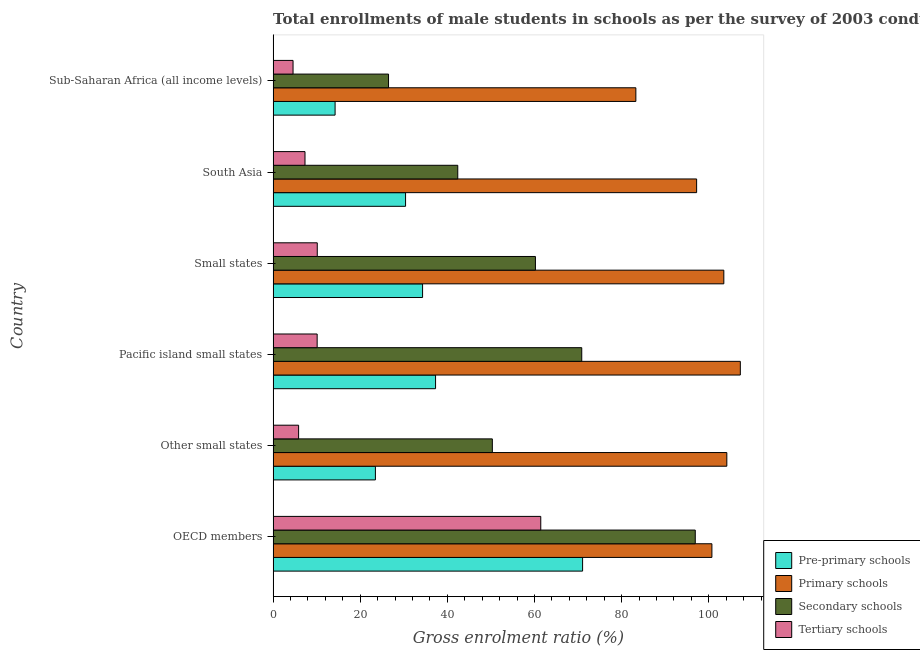How many different coloured bars are there?
Keep it short and to the point. 4. How many bars are there on the 6th tick from the top?
Provide a succinct answer. 4. How many bars are there on the 6th tick from the bottom?
Provide a short and direct response. 4. What is the label of the 1st group of bars from the top?
Give a very brief answer. Sub-Saharan Africa (all income levels). In how many cases, is the number of bars for a given country not equal to the number of legend labels?
Provide a succinct answer. 0. What is the gross enrolment ratio(male) in tertiary schools in Sub-Saharan Africa (all income levels)?
Provide a succinct answer. 4.57. Across all countries, what is the maximum gross enrolment ratio(male) in pre-primary schools?
Provide a short and direct response. 71.04. Across all countries, what is the minimum gross enrolment ratio(male) in secondary schools?
Provide a short and direct response. 26.49. In which country was the gross enrolment ratio(male) in primary schools maximum?
Give a very brief answer. Pacific island small states. In which country was the gross enrolment ratio(male) in primary schools minimum?
Your answer should be very brief. Sub-Saharan Africa (all income levels). What is the total gross enrolment ratio(male) in primary schools in the graph?
Offer a terse response. 596.04. What is the difference between the gross enrolment ratio(male) in secondary schools in South Asia and that in Sub-Saharan Africa (all income levels)?
Your answer should be compact. 15.89. What is the difference between the gross enrolment ratio(male) in secondary schools in South Asia and the gross enrolment ratio(male) in tertiary schools in OECD members?
Ensure brevity in your answer.  -19.05. What is the average gross enrolment ratio(male) in primary schools per country?
Offer a terse response. 99.34. What is the difference between the gross enrolment ratio(male) in pre-primary schools and gross enrolment ratio(male) in tertiary schools in Pacific island small states?
Offer a very short reply. 27.18. In how many countries, is the gross enrolment ratio(male) in secondary schools greater than 108 %?
Provide a short and direct response. 0. What is the ratio of the gross enrolment ratio(male) in primary schools in Other small states to that in Pacific island small states?
Ensure brevity in your answer.  0.97. Is the difference between the gross enrolment ratio(male) in tertiary schools in OECD members and Small states greater than the difference between the gross enrolment ratio(male) in secondary schools in OECD members and Small states?
Offer a terse response. Yes. What is the difference between the highest and the second highest gross enrolment ratio(male) in secondary schools?
Offer a terse response. 26.06. What is the difference between the highest and the lowest gross enrolment ratio(male) in primary schools?
Your response must be concise. 23.98. Is the sum of the gross enrolment ratio(male) in primary schools in Small states and Sub-Saharan Africa (all income levels) greater than the maximum gross enrolment ratio(male) in secondary schools across all countries?
Give a very brief answer. Yes. Is it the case that in every country, the sum of the gross enrolment ratio(male) in pre-primary schools and gross enrolment ratio(male) in tertiary schools is greater than the sum of gross enrolment ratio(male) in secondary schools and gross enrolment ratio(male) in primary schools?
Give a very brief answer. No. What does the 1st bar from the top in OECD members represents?
Offer a very short reply. Tertiary schools. What does the 2nd bar from the bottom in Pacific island small states represents?
Your answer should be very brief. Primary schools. How many bars are there?
Offer a very short reply. 24. How many countries are there in the graph?
Your answer should be compact. 6. Where does the legend appear in the graph?
Ensure brevity in your answer.  Bottom right. How many legend labels are there?
Offer a terse response. 4. What is the title of the graph?
Your response must be concise. Total enrollments of male students in schools as per the survey of 2003 conducted in different countries. What is the label or title of the X-axis?
Keep it short and to the point. Gross enrolment ratio (%). What is the label or title of the Y-axis?
Ensure brevity in your answer.  Country. What is the Gross enrolment ratio (%) in Pre-primary schools in OECD members?
Your answer should be compact. 71.04. What is the Gross enrolment ratio (%) in Primary schools in OECD members?
Your answer should be very brief. 100.72. What is the Gross enrolment ratio (%) of Secondary schools in OECD members?
Provide a succinct answer. 96.9. What is the Gross enrolment ratio (%) of Tertiary schools in OECD members?
Offer a terse response. 61.44. What is the Gross enrolment ratio (%) in Pre-primary schools in Other small states?
Give a very brief answer. 23.48. What is the Gross enrolment ratio (%) of Primary schools in Other small states?
Give a very brief answer. 104.15. What is the Gross enrolment ratio (%) of Secondary schools in Other small states?
Offer a terse response. 50.32. What is the Gross enrolment ratio (%) of Tertiary schools in Other small states?
Give a very brief answer. 5.85. What is the Gross enrolment ratio (%) in Pre-primary schools in Pacific island small states?
Your response must be concise. 37.29. What is the Gross enrolment ratio (%) in Primary schools in Pacific island small states?
Provide a succinct answer. 107.25. What is the Gross enrolment ratio (%) in Secondary schools in Pacific island small states?
Ensure brevity in your answer.  70.84. What is the Gross enrolment ratio (%) in Tertiary schools in Pacific island small states?
Keep it short and to the point. 10.11. What is the Gross enrolment ratio (%) in Pre-primary schools in Small states?
Your answer should be very brief. 34.31. What is the Gross enrolment ratio (%) of Primary schools in Small states?
Make the answer very short. 103.46. What is the Gross enrolment ratio (%) of Secondary schools in Small states?
Keep it short and to the point. 60.21. What is the Gross enrolment ratio (%) in Tertiary schools in Small states?
Ensure brevity in your answer.  10.13. What is the Gross enrolment ratio (%) in Pre-primary schools in South Asia?
Give a very brief answer. 30.4. What is the Gross enrolment ratio (%) in Primary schools in South Asia?
Your answer should be very brief. 97.21. What is the Gross enrolment ratio (%) in Secondary schools in South Asia?
Provide a short and direct response. 42.38. What is the Gross enrolment ratio (%) in Tertiary schools in South Asia?
Make the answer very short. 7.32. What is the Gross enrolment ratio (%) of Pre-primary schools in Sub-Saharan Africa (all income levels)?
Ensure brevity in your answer.  14.22. What is the Gross enrolment ratio (%) of Primary schools in Sub-Saharan Africa (all income levels)?
Give a very brief answer. 83.26. What is the Gross enrolment ratio (%) of Secondary schools in Sub-Saharan Africa (all income levels)?
Offer a very short reply. 26.49. What is the Gross enrolment ratio (%) of Tertiary schools in Sub-Saharan Africa (all income levels)?
Give a very brief answer. 4.57. Across all countries, what is the maximum Gross enrolment ratio (%) in Pre-primary schools?
Make the answer very short. 71.04. Across all countries, what is the maximum Gross enrolment ratio (%) in Primary schools?
Your answer should be very brief. 107.25. Across all countries, what is the maximum Gross enrolment ratio (%) in Secondary schools?
Your response must be concise. 96.9. Across all countries, what is the maximum Gross enrolment ratio (%) in Tertiary schools?
Provide a succinct answer. 61.44. Across all countries, what is the minimum Gross enrolment ratio (%) of Pre-primary schools?
Your answer should be very brief. 14.22. Across all countries, what is the minimum Gross enrolment ratio (%) in Primary schools?
Provide a short and direct response. 83.26. Across all countries, what is the minimum Gross enrolment ratio (%) of Secondary schools?
Provide a short and direct response. 26.49. Across all countries, what is the minimum Gross enrolment ratio (%) in Tertiary schools?
Your response must be concise. 4.57. What is the total Gross enrolment ratio (%) of Pre-primary schools in the graph?
Offer a terse response. 210.74. What is the total Gross enrolment ratio (%) in Primary schools in the graph?
Make the answer very short. 596.04. What is the total Gross enrolment ratio (%) in Secondary schools in the graph?
Ensure brevity in your answer.  347.14. What is the total Gross enrolment ratio (%) of Tertiary schools in the graph?
Your response must be concise. 99.42. What is the difference between the Gross enrolment ratio (%) in Pre-primary schools in OECD members and that in Other small states?
Give a very brief answer. 47.56. What is the difference between the Gross enrolment ratio (%) in Primary schools in OECD members and that in Other small states?
Your answer should be compact. -3.43. What is the difference between the Gross enrolment ratio (%) in Secondary schools in OECD members and that in Other small states?
Give a very brief answer. 46.58. What is the difference between the Gross enrolment ratio (%) of Tertiary schools in OECD members and that in Other small states?
Provide a succinct answer. 55.59. What is the difference between the Gross enrolment ratio (%) in Pre-primary schools in OECD members and that in Pacific island small states?
Provide a succinct answer. 33.75. What is the difference between the Gross enrolment ratio (%) in Primary schools in OECD members and that in Pacific island small states?
Your response must be concise. -6.53. What is the difference between the Gross enrolment ratio (%) in Secondary schools in OECD members and that in Pacific island small states?
Your response must be concise. 26.06. What is the difference between the Gross enrolment ratio (%) of Tertiary schools in OECD members and that in Pacific island small states?
Your answer should be compact. 51.33. What is the difference between the Gross enrolment ratio (%) in Pre-primary schools in OECD members and that in Small states?
Your response must be concise. 36.73. What is the difference between the Gross enrolment ratio (%) of Primary schools in OECD members and that in Small states?
Offer a terse response. -2.74. What is the difference between the Gross enrolment ratio (%) of Secondary schools in OECD members and that in Small states?
Keep it short and to the point. 36.69. What is the difference between the Gross enrolment ratio (%) of Tertiary schools in OECD members and that in Small states?
Your answer should be compact. 51.3. What is the difference between the Gross enrolment ratio (%) of Pre-primary schools in OECD members and that in South Asia?
Make the answer very short. 40.64. What is the difference between the Gross enrolment ratio (%) of Primary schools in OECD members and that in South Asia?
Offer a very short reply. 3.51. What is the difference between the Gross enrolment ratio (%) in Secondary schools in OECD members and that in South Asia?
Keep it short and to the point. 54.52. What is the difference between the Gross enrolment ratio (%) of Tertiary schools in OECD members and that in South Asia?
Provide a succinct answer. 54.12. What is the difference between the Gross enrolment ratio (%) of Pre-primary schools in OECD members and that in Sub-Saharan Africa (all income levels)?
Keep it short and to the point. 56.81. What is the difference between the Gross enrolment ratio (%) of Primary schools in OECD members and that in Sub-Saharan Africa (all income levels)?
Offer a terse response. 17.46. What is the difference between the Gross enrolment ratio (%) in Secondary schools in OECD members and that in Sub-Saharan Africa (all income levels)?
Offer a terse response. 70.41. What is the difference between the Gross enrolment ratio (%) of Tertiary schools in OECD members and that in Sub-Saharan Africa (all income levels)?
Give a very brief answer. 56.86. What is the difference between the Gross enrolment ratio (%) in Pre-primary schools in Other small states and that in Pacific island small states?
Your answer should be very brief. -13.81. What is the difference between the Gross enrolment ratio (%) of Primary schools in Other small states and that in Pacific island small states?
Your response must be concise. -3.1. What is the difference between the Gross enrolment ratio (%) of Secondary schools in Other small states and that in Pacific island small states?
Your answer should be very brief. -20.52. What is the difference between the Gross enrolment ratio (%) of Tertiary schools in Other small states and that in Pacific island small states?
Your answer should be very brief. -4.26. What is the difference between the Gross enrolment ratio (%) of Pre-primary schools in Other small states and that in Small states?
Your answer should be very brief. -10.83. What is the difference between the Gross enrolment ratio (%) of Primary schools in Other small states and that in Small states?
Provide a short and direct response. 0.69. What is the difference between the Gross enrolment ratio (%) in Secondary schools in Other small states and that in Small states?
Offer a very short reply. -9.89. What is the difference between the Gross enrolment ratio (%) of Tertiary schools in Other small states and that in Small states?
Your answer should be very brief. -4.28. What is the difference between the Gross enrolment ratio (%) of Pre-primary schools in Other small states and that in South Asia?
Your response must be concise. -6.92. What is the difference between the Gross enrolment ratio (%) of Primary schools in Other small states and that in South Asia?
Ensure brevity in your answer.  6.94. What is the difference between the Gross enrolment ratio (%) in Secondary schools in Other small states and that in South Asia?
Your response must be concise. 7.94. What is the difference between the Gross enrolment ratio (%) of Tertiary schools in Other small states and that in South Asia?
Give a very brief answer. -1.47. What is the difference between the Gross enrolment ratio (%) in Pre-primary schools in Other small states and that in Sub-Saharan Africa (all income levels)?
Make the answer very short. 9.25. What is the difference between the Gross enrolment ratio (%) of Primary schools in Other small states and that in Sub-Saharan Africa (all income levels)?
Your response must be concise. 20.88. What is the difference between the Gross enrolment ratio (%) of Secondary schools in Other small states and that in Sub-Saharan Africa (all income levels)?
Offer a very short reply. 23.83. What is the difference between the Gross enrolment ratio (%) of Tertiary schools in Other small states and that in Sub-Saharan Africa (all income levels)?
Give a very brief answer. 1.28. What is the difference between the Gross enrolment ratio (%) of Pre-primary schools in Pacific island small states and that in Small states?
Offer a very short reply. 2.98. What is the difference between the Gross enrolment ratio (%) of Primary schools in Pacific island small states and that in Small states?
Ensure brevity in your answer.  3.79. What is the difference between the Gross enrolment ratio (%) in Secondary schools in Pacific island small states and that in Small states?
Your answer should be compact. 10.63. What is the difference between the Gross enrolment ratio (%) in Tertiary schools in Pacific island small states and that in Small states?
Your response must be concise. -0.03. What is the difference between the Gross enrolment ratio (%) in Pre-primary schools in Pacific island small states and that in South Asia?
Give a very brief answer. 6.89. What is the difference between the Gross enrolment ratio (%) in Primary schools in Pacific island small states and that in South Asia?
Ensure brevity in your answer.  10.04. What is the difference between the Gross enrolment ratio (%) of Secondary schools in Pacific island small states and that in South Asia?
Provide a short and direct response. 28.46. What is the difference between the Gross enrolment ratio (%) in Tertiary schools in Pacific island small states and that in South Asia?
Your answer should be very brief. 2.79. What is the difference between the Gross enrolment ratio (%) in Pre-primary schools in Pacific island small states and that in Sub-Saharan Africa (all income levels)?
Provide a succinct answer. 23.06. What is the difference between the Gross enrolment ratio (%) of Primary schools in Pacific island small states and that in Sub-Saharan Africa (all income levels)?
Provide a short and direct response. 23.98. What is the difference between the Gross enrolment ratio (%) of Secondary schools in Pacific island small states and that in Sub-Saharan Africa (all income levels)?
Offer a very short reply. 44.35. What is the difference between the Gross enrolment ratio (%) in Tertiary schools in Pacific island small states and that in Sub-Saharan Africa (all income levels)?
Your response must be concise. 5.53. What is the difference between the Gross enrolment ratio (%) in Pre-primary schools in Small states and that in South Asia?
Your answer should be very brief. 3.91. What is the difference between the Gross enrolment ratio (%) of Primary schools in Small states and that in South Asia?
Ensure brevity in your answer.  6.25. What is the difference between the Gross enrolment ratio (%) of Secondary schools in Small states and that in South Asia?
Your response must be concise. 17.83. What is the difference between the Gross enrolment ratio (%) of Tertiary schools in Small states and that in South Asia?
Offer a very short reply. 2.81. What is the difference between the Gross enrolment ratio (%) in Pre-primary schools in Small states and that in Sub-Saharan Africa (all income levels)?
Ensure brevity in your answer.  20.08. What is the difference between the Gross enrolment ratio (%) of Primary schools in Small states and that in Sub-Saharan Africa (all income levels)?
Ensure brevity in your answer.  20.2. What is the difference between the Gross enrolment ratio (%) of Secondary schools in Small states and that in Sub-Saharan Africa (all income levels)?
Offer a very short reply. 33.72. What is the difference between the Gross enrolment ratio (%) in Tertiary schools in Small states and that in Sub-Saharan Africa (all income levels)?
Keep it short and to the point. 5.56. What is the difference between the Gross enrolment ratio (%) of Pre-primary schools in South Asia and that in Sub-Saharan Africa (all income levels)?
Your answer should be compact. 16.18. What is the difference between the Gross enrolment ratio (%) of Primary schools in South Asia and that in Sub-Saharan Africa (all income levels)?
Provide a succinct answer. 13.95. What is the difference between the Gross enrolment ratio (%) in Secondary schools in South Asia and that in Sub-Saharan Africa (all income levels)?
Provide a short and direct response. 15.89. What is the difference between the Gross enrolment ratio (%) of Tertiary schools in South Asia and that in Sub-Saharan Africa (all income levels)?
Your response must be concise. 2.74. What is the difference between the Gross enrolment ratio (%) of Pre-primary schools in OECD members and the Gross enrolment ratio (%) of Primary schools in Other small states?
Your answer should be compact. -33.11. What is the difference between the Gross enrolment ratio (%) in Pre-primary schools in OECD members and the Gross enrolment ratio (%) in Secondary schools in Other small states?
Give a very brief answer. 20.72. What is the difference between the Gross enrolment ratio (%) of Pre-primary schools in OECD members and the Gross enrolment ratio (%) of Tertiary schools in Other small states?
Offer a very short reply. 65.19. What is the difference between the Gross enrolment ratio (%) of Primary schools in OECD members and the Gross enrolment ratio (%) of Secondary schools in Other small states?
Your response must be concise. 50.4. What is the difference between the Gross enrolment ratio (%) of Primary schools in OECD members and the Gross enrolment ratio (%) of Tertiary schools in Other small states?
Provide a short and direct response. 94.87. What is the difference between the Gross enrolment ratio (%) in Secondary schools in OECD members and the Gross enrolment ratio (%) in Tertiary schools in Other small states?
Offer a very short reply. 91.05. What is the difference between the Gross enrolment ratio (%) of Pre-primary schools in OECD members and the Gross enrolment ratio (%) of Primary schools in Pacific island small states?
Your answer should be compact. -36.21. What is the difference between the Gross enrolment ratio (%) in Pre-primary schools in OECD members and the Gross enrolment ratio (%) in Secondary schools in Pacific island small states?
Offer a very short reply. 0.2. What is the difference between the Gross enrolment ratio (%) in Pre-primary schools in OECD members and the Gross enrolment ratio (%) in Tertiary schools in Pacific island small states?
Your answer should be very brief. 60.93. What is the difference between the Gross enrolment ratio (%) in Primary schools in OECD members and the Gross enrolment ratio (%) in Secondary schools in Pacific island small states?
Your answer should be compact. 29.88. What is the difference between the Gross enrolment ratio (%) of Primary schools in OECD members and the Gross enrolment ratio (%) of Tertiary schools in Pacific island small states?
Keep it short and to the point. 90.61. What is the difference between the Gross enrolment ratio (%) in Secondary schools in OECD members and the Gross enrolment ratio (%) in Tertiary schools in Pacific island small states?
Your answer should be very brief. 86.79. What is the difference between the Gross enrolment ratio (%) of Pre-primary schools in OECD members and the Gross enrolment ratio (%) of Primary schools in Small states?
Keep it short and to the point. -32.42. What is the difference between the Gross enrolment ratio (%) in Pre-primary schools in OECD members and the Gross enrolment ratio (%) in Secondary schools in Small states?
Offer a terse response. 10.83. What is the difference between the Gross enrolment ratio (%) in Pre-primary schools in OECD members and the Gross enrolment ratio (%) in Tertiary schools in Small states?
Give a very brief answer. 60.9. What is the difference between the Gross enrolment ratio (%) in Primary schools in OECD members and the Gross enrolment ratio (%) in Secondary schools in Small states?
Your answer should be very brief. 40.51. What is the difference between the Gross enrolment ratio (%) in Primary schools in OECD members and the Gross enrolment ratio (%) in Tertiary schools in Small states?
Keep it short and to the point. 90.59. What is the difference between the Gross enrolment ratio (%) of Secondary schools in OECD members and the Gross enrolment ratio (%) of Tertiary schools in Small states?
Offer a very short reply. 86.77. What is the difference between the Gross enrolment ratio (%) of Pre-primary schools in OECD members and the Gross enrolment ratio (%) of Primary schools in South Asia?
Your response must be concise. -26.17. What is the difference between the Gross enrolment ratio (%) of Pre-primary schools in OECD members and the Gross enrolment ratio (%) of Secondary schools in South Asia?
Offer a terse response. 28.66. What is the difference between the Gross enrolment ratio (%) in Pre-primary schools in OECD members and the Gross enrolment ratio (%) in Tertiary schools in South Asia?
Provide a short and direct response. 63.72. What is the difference between the Gross enrolment ratio (%) of Primary schools in OECD members and the Gross enrolment ratio (%) of Secondary schools in South Asia?
Make the answer very short. 58.34. What is the difference between the Gross enrolment ratio (%) of Primary schools in OECD members and the Gross enrolment ratio (%) of Tertiary schools in South Asia?
Ensure brevity in your answer.  93.4. What is the difference between the Gross enrolment ratio (%) in Secondary schools in OECD members and the Gross enrolment ratio (%) in Tertiary schools in South Asia?
Provide a succinct answer. 89.58. What is the difference between the Gross enrolment ratio (%) of Pre-primary schools in OECD members and the Gross enrolment ratio (%) of Primary schools in Sub-Saharan Africa (all income levels)?
Your answer should be compact. -12.22. What is the difference between the Gross enrolment ratio (%) in Pre-primary schools in OECD members and the Gross enrolment ratio (%) in Secondary schools in Sub-Saharan Africa (all income levels)?
Your answer should be very brief. 44.55. What is the difference between the Gross enrolment ratio (%) in Pre-primary schools in OECD members and the Gross enrolment ratio (%) in Tertiary schools in Sub-Saharan Africa (all income levels)?
Your answer should be very brief. 66.46. What is the difference between the Gross enrolment ratio (%) of Primary schools in OECD members and the Gross enrolment ratio (%) of Secondary schools in Sub-Saharan Africa (all income levels)?
Provide a succinct answer. 74.23. What is the difference between the Gross enrolment ratio (%) in Primary schools in OECD members and the Gross enrolment ratio (%) in Tertiary schools in Sub-Saharan Africa (all income levels)?
Ensure brevity in your answer.  96.14. What is the difference between the Gross enrolment ratio (%) of Secondary schools in OECD members and the Gross enrolment ratio (%) of Tertiary schools in Sub-Saharan Africa (all income levels)?
Offer a terse response. 92.32. What is the difference between the Gross enrolment ratio (%) of Pre-primary schools in Other small states and the Gross enrolment ratio (%) of Primary schools in Pacific island small states?
Offer a terse response. -83.77. What is the difference between the Gross enrolment ratio (%) of Pre-primary schools in Other small states and the Gross enrolment ratio (%) of Secondary schools in Pacific island small states?
Give a very brief answer. -47.36. What is the difference between the Gross enrolment ratio (%) of Pre-primary schools in Other small states and the Gross enrolment ratio (%) of Tertiary schools in Pacific island small states?
Provide a short and direct response. 13.37. What is the difference between the Gross enrolment ratio (%) of Primary schools in Other small states and the Gross enrolment ratio (%) of Secondary schools in Pacific island small states?
Provide a short and direct response. 33.3. What is the difference between the Gross enrolment ratio (%) of Primary schools in Other small states and the Gross enrolment ratio (%) of Tertiary schools in Pacific island small states?
Keep it short and to the point. 94.04. What is the difference between the Gross enrolment ratio (%) of Secondary schools in Other small states and the Gross enrolment ratio (%) of Tertiary schools in Pacific island small states?
Your response must be concise. 40.21. What is the difference between the Gross enrolment ratio (%) of Pre-primary schools in Other small states and the Gross enrolment ratio (%) of Primary schools in Small states?
Your response must be concise. -79.98. What is the difference between the Gross enrolment ratio (%) in Pre-primary schools in Other small states and the Gross enrolment ratio (%) in Secondary schools in Small states?
Ensure brevity in your answer.  -36.73. What is the difference between the Gross enrolment ratio (%) of Pre-primary schools in Other small states and the Gross enrolment ratio (%) of Tertiary schools in Small states?
Offer a terse response. 13.35. What is the difference between the Gross enrolment ratio (%) in Primary schools in Other small states and the Gross enrolment ratio (%) in Secondary schools in Small states?
Offer a very short reply. 43.94. What is the difference between the Gross enrolment ratio (%) of Primary schools in Other small states and the Gross enrolment ratio (%) of Tertiary schools in Small states?
Offer a terse response. 94.01. What is the difference between the Gross enrolment ratio (%) of Secondary schools in Other small states and the Gross enrolment ratio (%) of Tertiary schools in Small states?
Your response must be concise. 40.19. What is the difference between the Gross enrolment ratio (%) in Pre-primary schools in Other small states and the Gross enrolment ratio (%) in Primary schools in South Asia?
Make the answer very short. -73.73. What is the difference between the Gross enrolment ratio (%) of Pre-primary schools in Other small states and the Gross enrolment ratio (%) of Secondary schools in South Asia?
Keep it short and to the point. -18.9. What is the difference between the Gross enrolment ratio (%) in Pre-primary schools in Other small states and the Gross enrolment ratio (%) in Tertiary schools in South Asia?
Provide a short and direct response. 16.16. What is the difference between the Gross enrolment ratio (%) in Primary schools in Other small states and the Gross enrolment ratio (%) in Secondary schools in South Asia?
Your answer should be compact. 61.76. What is the difference between the Gross enrolment ratio (%) of Primary schools in Other small states and the Gross enrolment ratio (%) of Tertiary schools in South Asia?
Your answer should be compact. 96.83. What is the difference between the Gross enrolment ratio (%) in Secondary schools in Other small states and the Gross enrolment ratio (%) in Tertiary schools in South Asia?
Your answer should be compact. 43. What is the difference between the Gross enrolment ratio (%) in Pre-primary schools in Other small states and the Gross enrolment ratio (%) in Primary schools in Sub-Saharan Africa (all income levels)?
Keep it short and to the point. -59.78. What is the difference between the Gross enrolment ratio (%) in Pre-primary schools in Other small states and the Gross enrolment ratio (%) in Secondary schools in Sub-Saharan Africa (all income levels)?
Keep it short and to the point. -3.01. What is the difference between the Gross enrolment ratio (%) of Pre-primary schools in Other small states and the Gross enrolment ratio (%) of Tertiary schools in Sub-Saharan Africa (all income levels)?
Your response must be concise. 18.9. What is the difference between the Gross enrolment ratio (%) in Primary schools in Other small states and the Gross enrolment ratio (%) in Secondary schools in Sub-Saharan Africa (all income levels)?
Keep it short and to the point. 77.66. What is the difference between the Gross enrolment ratio (%) in Primary schools in Other small states and the Gross enrolment ratio (%) in Tertiary schools in Sub-Saharan Africa (all income levels)?
Provide a short and direct response. 99.57. What is the difference between the Gross enrolment ratio (%) in Secondary schools in Other small states and the Gross enrolment ratio (%) in Tertiary schools in Sub-Saharan Africa (all income levels)?
Keep it short and to the point. 45.75. What is the difference between the Gross enrolment ratio (%) of Pre-primary schools in Pacific island small states and the Gross enrolment ratio (%) of Primary schools in Small states?
Ensure brevity in your answer.  -66.17. What is the difference between the Gross enrolment ratio (%) in Pre-primary schools in Pacific island small states and the Gross enrolment ratio (%) in Secondary schools in Small states?
Your answer should be very brief. -22.92. What is the difference between the Gross enrolment ratio (%) of Pre-primary schools in Pacific island small states and the Gross enrolment ratio (%) of Tertiary schools in Small states?
Offer a very short reply. 27.16. What is the difference between the Gross enrolment ratio (%) of Primary schools in Pacific island small states and the Gross enrolment ratio (%) of Secondary schools in Small states?
Provide a succinct answer. 47.04. What is the difference between the Gross enrolment ratio (%) in Primary schools in Pacific island small states and the Gross enrolment ratio (%) in Tertiary schools in Small states?
Your answer should be compact. 97.11. What is the difference between the Gross enrolment ratio (%) in Secondary schools in Pacific island small states and the Gross enrolment ratio (%) in Tertiary schools in Small states?
Your answer should be very brief. 60.71. What is the difference between the Gross enrolment ratio (%) in Pre-primary schools in Pacific island small states and the Gross enrolment ratio (%) in Primary schools in South Asia?
Provide a short and direct response. -59.92. What is the difference between the Gross enrolment ratio (%) of Pre-primary schools in Pacific island small states and the Gross enrolment ratio (%) of Secondary schools in South Asia?
Offer a terse response. -5.09. What is the difference between the Gross enrolment ratio (%) of Pre-primary schools in Pacific island small states and the Gross enrolment ratio (%) of Tertiary schools in South Asia?
Make the answer very short. 29.97. What is the difference between the Gross enrolment ratio (%) of Primary schools in Pacific island small states and the Gross enrolment ratio (%) of Secondary schools in South Asia?
Provide a succinct answer. 64.86. What is the difference between the Gross enrolment ratio (%) of Primary schools in Pacific island small states and the Gross enrolment ratio (%) of Tertiary schools in South Asia?
Provide a succinct answer. 99.93. What is the difference between the Gross enrolment ratio (%) of Secondary schools in Pacific island small states and the Gross enrolment ratio (%) of Tertiary schools in South Asia?
Provide a short and direct response. 63.52. What is the difference between the Gross enrolment ratio (%) of Pre-primary schools in Pacific island small states and the Gross enrolment ratio (%) of Primary schools in Sub-Saharan Africa (all income levels)?
Provide a succinct answer. -45.97. What is the difference between the Gross enrolment ratio (%) of Pre-primary schools in Pacific island small states and the Gross enrolment ratio (%) of Secondary schools in Sub-Saharan Africa (all income levels)?
Your answer should be very brief. 10.8. What is the difference between the Gross enrolment ratio (%) in Pre-primary schools in Pacific island small states and the Gross enrolment ratio (%) in Tertiary schools in Sub-Saharan Africa (all income levels)?
Keep it short and to the point. 32.71. What is the difference between the Gross enrolment ratio (%) in Primary schools in Pacific island small states and the Gross enrolment ratio (%) in Secondary schools in Sub-Saharan Africa (all income levels)?
Offer a terse response. 80.75. What is the difference between the Gross enrolment ratio (%) in Primary schools in Pacific island small states and the Gross enrolment ratio (%) in Tertiary schools in Sub-Saharan Africa (all income levels)?
Provide a short and direct response. 102.67. What is the difference between the Gross enrolment ratio (%) of Secondary schools in Pacific island small states and the Gross enrolment ratio (%) of Tertiary schools in Sub-Saharan Africa (all income levels)?
Keep it short and to the point. 66.27. What is the difference between the Gross enrolment ratio (%) of Pre-primary schools in Small states and the Gross enrolment ratio (%) of Primary schools in South Asia?
Keep it short and to the point. -62.9. What is the difference between the Gross enrolment ratio (%) in Pre-primary schools in Small states and the Gross enrolment ratio (%) in Secondary schools in South Asia?
Ensure brevity in your answer.  -8.08. What is the difference between the Gross enrolment ratio (%) in Pre-primary schools in Small states and the Gross enrolment ratio (%) in Tertiary schools in South Asia?
Give a very brief answer. 26.99. What is the difference between the Gross enrolment ratio (%) in Primary schools in Small states and the Gross enrolment ratio (%) in Secondary schools in South Asia?
Make the answer very short. 61.08. What is the difference between the Gross enrolment ratio (%) of Primary schools in Small states and the Gross enrolment ratio (%) of Tertiary schools in South Asia?
Your answer should be compact. 96.14. What is the difference between the Gross enrolment ratio (%) in Secondary schools in Small states and the Gross enrolment ratio (%) in Tertiary schools in South Asia?
Your response must be concise. 52.89. What is the difference between the Gross enrolment ratio (%) in Pre-primary schools in Small states and the Gross enrolment ratio (%) in Primary schools in Sub-Saharan Africa (all income levels)?
Your response must be concise. -48.96. What is the difference between the Gross enrolment ratio (%) in Pre-primary schools in Small states and the Gross enrolment ratio (%) in Secondary schools in Sub-Saharan Africa (all income levels)?
Ensure brevity in your answer.  7.81. What is the difference between the Gross enrolment ratio (%) in Pre-primary schools in Small states and the Gross enrolment ratio (%) in Tertiary schools in Sub-Saharan Africa (all income levels)?
Offer a terse response. 29.73. What is the difference between the Gross enrolment ratio (%) of Primary schools in Small states and the Gross enrolment ratio (%) of Secondary schools in Sub-Saharan Africa (all income levels)?
Ensure brevity in your answer.  76.97. What is the difference between the Gross enrolment ratio (%) in Primary schools in Small states and the Gross enrolment ratio (%) in Tertiary schools in Sub-Saharan Africa (all income levels)?
Your answer should be compact. 98.88. What is the difference between the Gross enrolment ratio (%) in Secondary schools in Small states and the Gross enrolment ratio (%) in Tertiary schools in Sub-Saharan Africa (all income levels)?
Your answer should be compact. 55.63. What is the difference between the Gross enrolment ratio (%) in Pre-primary schools in South Asia and the Gross enrolment ratio (%) in Primary schools in Sub-Saharan Africa (all income levels)?
Give a very brief answer. -52.86. What is the difference between the Gross enrolment ratio (%) of Pre-primary schools in South Asia and the Gross enrolment ratio (%) of Secondary schools in Sub-Saharan Africa (all income levels)?
Offer a very short reply. 3.91. What is the difference between the Gross enrolment ratio (%) of Pre-primary schools in South Asia and the Gross enrolment ratio (%) of Tertiary schools in Sub-Saharan Africa (all income levels)?
Provide a succinct answer. 25.83. What is the difference between the Gross enrolment ratio (%) of Primary schools in South Asia and the Gross enrolment ratio (%) of Secondary schools in Sub-Saharan Africa (all income levels)?
Keep it short and to the point. 70.72. What is the difference between the Gross enrolment ratio (%) in Primary schools in South Asia and the Gross enrolment ratio (%) in Tertiary schools in Sub-Saharan Africa (all income levels)?
Offer a very short reply. 92.64. What is the difference between the Gross enrolment ratio (%) in Secondary schools in South Asia and the Gross enrolment ratio (%) in Tertiary schools in Sub-Saharan Africa (all income levels)?
Offer a terse response. 37.81. What is the average Gross enrolment ratio (%) of Pre-primary schools per country?
Provide a succinct answer. 35.12. What is the average Gross enrolment ratio (%) of Primary schools per country?
Offer a very short reply. 99.34. What is the average Gross enrolment ratio (%) of Secondary schools per country?
Your response must be concise. 57.86. What is the average Gross enrolment ratio (%) of Tertiary schools per country?
Keep it short and to the point. 16.57. What is the difference between the Gross enrolment ratio (%) of Pre-primary schools and Gross enrolment ratio (%) of Primary schools in OECD members?
Offer a terse response. -29.68. What is the difference between the Gross enrolment ratio (%) of Pre-primary schools and Gross enrolment ratio (%) of Secondary schools in OECD members?
Your answer should be very brief. -25.86. What is the difference between the Gross enrolment ratio (%) of Pre-primary schools and Gross enrolment ratio (%) of Tertiary schools in OECD members?
Offer a very short reply. 9.6. What is the difference between the Gross enrolment ratio (%) of Primary schools and Gross enrolment ratio (%) of Secondary schools in OECD members?
Provide a succinct answer. 3.82. What is the difference between the Gross enrolment ratio (%) of Primary schools and Gross enrolment ratio (%) of Tertiary schools in OECD members?
Provide a succinct answer. 39.28. What is the difference between the Gross enrolment ratio (%) in Secondary schools and Gross enrolment ratio (%) in Tertiary schools in OECD members?
Provide a short and direct response. 35.46. What is the difference between the Gross enrolment ratio (%) of Pre-primary schools and Gross enrolment ratio (%) of Primary schools in Other small states?
Ensure brevity in your answer.  -80.67. What is the difference between the Gross enrolment ratio (%) of Pre-primary schools and Gross enrolment ratio (%) of Secondary schools in Other small states?
Ensure brevity in your answer.  -26.84. What is the difference between the Gross enrolment ratio (%) in Pre-primary schools and Gross enrolment ratio (%) in Tertiary schools in Other small states?
Your answer should be very brief. 17.63. What is the difference between the Gross enrolment ratio (%) in Primary schools and Gross enrolment ratio (%) in Secondary schools in Other small states?
Provide a succinct answer. 53.83. What is the difference between the Gross enrolment ratio (%) in Primary schools and Gross enrolment ratio (%) in Tertiary schools in Other small states?
Your response must be concise. 98.3. What is the difference between the Gross enrolment ratio (%) in Secondary schools and Gross enrolment ratio (%) in Tertiary schools in Other small states?
Provide a short and direct response. 44.47. What is the difference between the Gross enrolment ratio (%) in Pre-primary schools and Gross enrolment ratio (%) in Primary schools in Pacific island small states?
Offer a terse response. -69.96. What is the difference between the Gross enrolment ratio (%) of Pre-primary schools and Gross enrolment ratio (%) of Secondary schools in Pacific island small states?
Keep it short and to the point. -33.55. What is the difference between the Gross enrolment ratio (%) in Pre-primary schools and Gross enrolment ratio (%) in Tertiary schools in Pacific island small states?
Give a very brief answer. 27.18. What is the difference between the Gross enrolment ratio (%) of Primary schools and Gross enrolment ratio (%) of Secondary schools in Pacific island small states?
Give a very brief answer. 36.4. What is the difference between the Gross enrolment ratio (%) of Primary schools and Gross enrolment ratio (%) of Tertiary schools in Pacific island small states?
Give a very brief answer. 97.14. What is the difference between the Gross enrolment ratio (%) of Secondary schools and Gross enrolment ratio (%) of Tertiary schools in Pacific island small states?
Provide a succinct answer. 60.73. What is the difference between the Gross enrolment ratio (%) of Pre-primary schools and Gross enrolment ratio (%) of Primary schools in Small states?
Keep it short and to the point. -69.15. What is the difference between the Gross enrolment ratio (%) of Pre-primary schools and Gross enrolment ratio (%) of Secondary schools in Small states?
Offer a very short reply. -25.9. What is the difference between the Gross enrolment ratio (%) of Pre-primary schools and Gross enrolment ratio (%) of Tertiary schools in Small states?
Offer a terse response. 24.17. What is the difference between the Gross enrolment ratio (%) of Primary schools and Gross enrolment ratio (%) of Secondary schools in Small states?
Give a very brief answer. 43.25. What is the difference between the Gross enrolment ratio (%) of Primary schools and Gross enrolment ratio (%) of Tertiary schools in Small states?
Offer a very short reply. 93.33. What is the difference between the Gross enrolment ratio (%) in Secondary schools and Gross enrolment ratio (%) in Tertiary schools in Small states?
Provide a short and direct response. 50.08. What is the difference between the Gross enrolment ratio (%) of Pre-primary schools and Gross enrolment ratio (%) of Primary schools in South Asia?
Ensure brevity in your answer.  -66.81. What is the difference between the Gross enrolment ratio (%) in Pre-primary schools and Gross enrolment ratio (%) in Secondary schools in South Asia?
Your answer should be very brief. -11.98. What is the difference between the Gross enrolment ratio (%) in Pre-primary schools and Gross enrolment ratio (%) in Tertiary schools in South Asia?
Ensure brevity in your answer.  23.08. What is the difference between the Gross enrolment ratio (%) of Primary schools and Gross enrolment ratio (%) of Secondary schools in South Asia?
Provide a short and direct response. 54.83. What is the difference between the Gross enrolment ratio (%) of Primary schools and Gross enrolment ratio (%) of Tertiary schools in South Asia?
Your response must be concise. 89.89. What is the difference between the Gross enrolment ratio (%) of Secondary schools and Gross enrolment ratio (%) of Tertiary schools in South Asia?
Provide a short and direct response. 35.06. What is the difference between the Gross enrolment ratio (%) in Pre-primary schools and Gross enrolment ratio (%) in Primary schools in Sub-Saharan Africa (all income levels)?
Your answer should be compact. -69.04. What is the difference between the Gross enrolment ratio (%) of Pre-primary schools and Gross enrolment ratio (%) of Secondary schools in Sub-Saharan Africa (all income levels)?
Ensure brevity in your answer.  -12.27. What is the difference between the Gross enrolment ratio (%) of Pre-primary schools and Gross enrolment ratio (%) of Tertiary schools in Sub-Saharan Africa (all income levels)?
Offer a terse response. 9.65. What is the difference between the Gross enrolment ratio (%) of Primary schools and Gross enrolment ratio (%) of Secondary schools in Sub-Saharan Africa (all income levels)?
Offer a very short reply. 56.77. What is the difference between the Gross enrolment ratio (%) of Primary schools and Gross enrolment ratio (%) of Tertiary schools in Sub-Saharan Africa (all income levels)?
Offer a very short reply. 78.69. What is the difference between the Gross enrolment ratio (%) in Secondary schools and Gross enrolment ratio (%) in Tertiary schools in Sub-Saharan Africa (all income levels)?
Provide a succinct answer. 21.92. What is the ratio of the Gross enrolment ratio (%) in Pre-primary schools in OECD members to that in Other small states?
Your answer should be very brief. 3.03. What is the ratio of the Gross enrolment ratio (%) in Primary schools in OECD members to that in Other small states?
Provide a short and direct response. 0.97. What is the ratio of the Gross enrolment ratio (%) of Secondary schools in OECD members to that in Other small states?
Your response must be concise. 1.93. What is the ratio of the Gross enrolment ratio (%) in Tertiary schools in OECD members to that in Other small states?
Offer a terse response. 10.5. What is the ratio of the Gross enrolment ratio (%) in Pre-primary schools in OECD members to that in Pacific island small states?
Your response must be concise. 1.91. What is the ratio of the Gross enrolment ratio (%) of Primary schools in OECD members to that in Pacific island small states?
Provide a succinct answer. 0.94. What is the ratio of the Gross enrolment ratio (%) of Secondary schools in OECD members to that in Pacific island small states?
Keep it short and to the point. 1.37. What is the ratio of the Gross enrolment ratio (%) in Tertiary schools in OECD members to that in Pacific island small states?
Your answer should be very brief. 6.08. What is the ratio of the Gross enrolment ratio (%) of Pre-primary schools in OECD members to that in Small states?
Your response must be concise. 2.07. What is the ratio of the Gross enrolment ratio (%) of Primary schools in OECD members to that in Small states?
Provide a short and direct response. 0.97. What is the ratio of the Gross enrolment ratio (%) of Secondary schools in OECD members to that in Small states?
Provide a succinct answer. 1.61. What is the ratio of the Gross enrolment ratio (%) of Tertiary schools in OECD members to that in Small states?
Keep it short and to the point. 6.06. What is the ratio of the Gross enrolment ratio (%) in Pre-primary schools in OECD members to that in South Asia?
Provide a succinct answer. 2.34. What is the ratio of the Gross enrolment ratio (%) in Primary schools in OECD members to that in South Asia?
Offer a terse response. 1.04. What is the ratio of the Gross enrolment ratio (%) of Secondary schools in OECD members to that in South Asia?
Offer a terse response. 2.29. What is the ratio of the Gross enrolment ratio (%) of Tertiary schools in OECD members to that in South Asia?
Make the answer very short. 8.39. What is the ratio of the Gross enrolment ratio (%) of Pre-primary schools in OECD members to that in Sub-Saharan Africa (all income levels)?
Offer a terse response. 4.99. What is the ratio of the Gross enrolment ratio (%) of Primary schools in OECD members to that in Sub-Saharan Africa (all income levels)?
Offer a very short reply. 1.21. What is the ratio of the Gross enrolment ratio (%) in Secondary schools in OECD members to that in Sub-Saharan Africa (all income levels)?
Offer a very short reply. 3.66. What is the ratio of the Gross enrolment ratio (%) of Tertiary schools in OECD members to that in Sub-Saharan Africa (all income levels)?
Provide a succinct answer. 13.43. What is the ratio of the Gross enrolment ratio (%) in Pre-primary schools in Other small states to that in Pacific island small states?
Offer a very short reply. 0.63. What is the ratio of the Gross enrolment ratio (%) of Primary schools in Other small states to that in Pacific island small states?
Offer a very short reply. 0.97. What is the ratio of the Gross enrolment ratio (%) in Secondary schools in Other small states to that in Pacific island small states?
Provide a short and direct response. 0.71. What is the ratio of the Gross enrolment ratio (%) in Tertiary schools in Other small states to that in Pacific island small states?
Offer a terse response. 0.58. What is the ratio of the Gross enrolment ratio (%) of Pre-primary schools in Other small states to that in Small states?
Give a very brief answer. 0.68. What is the ratio of the Gross enrolment ratio (%) in Primary schools in Other small states to that in Small states?
Your answer should be compact. 1.01. What is the ratio of the Gross enrolment ratio (%) of Secondary schools in Other small states to that in Small states?
Your answer should be compact. 0.84. What is the ratio of the Gross enrolment ratio (%) of Tertiary schools in Other small states to that in Small states?
Your answer should be very brief. 0.58. What is the ratio of the Gross enrolment ratio (%) of Pre-primary schools in Other small states to that in South Asia?
Make the answer very short. 0.77. What is the ratio of the Gross enrolment ratio (%) of Primary schools in Other small states to that in South Asia?
Your answer should be compact. 1.07. What is the ratio of the Gross enrolment ratio (%) of Secondary schools in Other small states to that in South Asia?
Ensure brevity in your answer.  1.19. What is the ratio of the Gross enrolment ratio (%) in Tertiary schools in Other small states to that in South Asia?
Make the answer very short. 0.8. What is the ratio of the Gross enrolment ratio (%) in Pre-primary schools in Other small states to that in Sub-Saharan Africa (all income levels)?
Your response must be concise. 1.65. What is the ratio of the Gross enrolment ratio (%) of Primary schools in Other small states to that in Sub-Saharan Africa (all income levels)?
Offer a terse response. 1.25. What is the ratio of the Gross enrolment ratio (%) in Secondary schools in Other small states to that in Sub-Saharan Africa (all income levels)?
Keep it short and to the point. 1.9. What is the ratio of the Gross enrolment ratio (%) in Tertiary schools in Other small states to that in Sub-Saharan Africa (all income levels)?
Your answer should be compact. 1.28. What is the ratio of the Gross enrolment ratio (%) in Pre-primary schools in Pacific island small states to that in Small states?
Provide a short and direct response. 1.09. What is the ratio of the Gross enrolment ratio (%) in Primary schools in Pacific island small states to that in Small states?
Provide a succinct answer. 1.04. What is the ratio of the Gross enrolment ratio (%) in Secondary schools in Pacific island small states to that in Small states?
Offer a very short reply. 1.18. What is the ratio of the Gross enrolment ratio (%) in Pre-primary schools in Pacific island small states to that in South Asia?
Ensure brevity in your answer.  1.23. What is the ratio of the Gross enrolment ratio (%) in Primary schools in Pacific island small states to that in South Asia?
Offer a very short reply. 1.1. What is the ratio of the Gross enrolment ratio (%) of Secondary schools in Pacific island small states to that in South Asia?
Keep it short and to the point. 1.67. What is the ratio of the Gross enrolment ratio (%) in Tertiary schools in Pacific island small states to that in South Asia?
Your answer should be compact. 1.38. What is the ratio of the Gross enrolment ratio (%) in Pre-primary schools in Pacific island small states to that in Sub-Saharan Africa (all income levels)?
Provide a short and direct response. 2.62. What is the ratio of the Gross enrolment ratio (%) in Primary schools in Pacific island small states to that in Sub-Saharan Africa (all income levels)?
Keep it short and to the point. 1.29. What is the ratio of the Gross enrolment ratio (%) in Secondary schools in Pacific island small states to that in Sub-Saharan Africa (all income levels)?
Make the answer very short. 2.67. What is the ratio of the Gross enrolment ratio (%) of Tertiary schools in Pacific island small states to that in Sub-Saharan Africa (all income levels)?
Your response must be concise. 2.21. What is the ratio of the Gross enrolment ratio (%) of Pre-primary schools in Small states to that in South Asia?
Provide a short and direct response. 1.13. What is the ratio of the Gross enrolment ratio (%) in Primary schools in Small states to that in South Asia?
Make the answer very short. 1.06. What is the ratio of the Gross enrolment ratio (%) in Secondary schools in Small states to that in South Asia?
Offer a terse response. 1.42. What is the ratio of the Gross enrolment ratio (%) of Tertiary schools in Small states to that in South Asia?
Keep it short and to the point. 1.38. What is the ratio of the Gross enrolment ratio (%) of Pre-primary schools in Small states to that in Sub-Saharan Africa (all income levels)?
Make the answer very short. 2.41. What is the ratio of the Gross enrolment ratio (%) of Primary schools in Small states to that in Sub-Saharan Africa (all income levels)?
Ensure brevity in your answer.  1.24. What is the ratio of the Gross enrolment ratio (%) in Secondary schools in Small states to that in Sub-Saharan Africa (all income levels)?
Offer a very short reply. 2.27. What is the ratio of the Gross enrolment ratio (%) in Tertiary schools in Small states to that in Sub-Saharan Africa (all income levels)?
Give a very brief answer. 2.22. What is the ratio of the Gross enrolment ratio (%) in Pre-primary schools in South Asia to that in Sub-Saharan Africa (all income levels)?
Provide a short and direct response. 2.14. What is the ratio of the Gross enrolment ratio (%) of Primary schools in South Asia to that in Sub-Saharan Africa (all income levels)?
Provide a succinct answer. 1.17. What is the ratio of the Gross enrolment ratio (%) in Secondary schools in South Asia to that in Sub-Saharan Africa (all income levels)?
Keep it short and to the point. 1.6. What is the ratio of the Gross enrolment ratio (%) in Tertiary schools in South Asia to that in Sub-Saharan Africa (all income levels)?
Ensure brevity in your answer.  1.6. What is the difference between the highest and the second highest Gross enrolment ratio (%) of Pre-primary schools?
Your response must be concise. 33.75. What is the difference between the highest and the second highest Gross enrolment ratio (%) in Primary schools?
Give a very brief answer. 3.1. What is the difference between the highest and the second highest Gross enrolment ratio (%) in Secondary schools?
Your response must be concise. 26.06. What is the difference between the highest and the second highest Gross enrolment ratio (%) of Tertiary schools?
Keep it short and to the point. 51.3. What is the difference between the highest and the lowest Gross enrolment ratio (%) in Pre-primary schools?
Your answer should be very brief. 56.81. What is the difference between the highest and the lowest Gross enrolment ratio (%) of Primary schools?
Keep it short and to the point. 23.98. What is the difference between the highest and the lowest Gross enrolment ratio (%) in Secondary schools?
Offer a very short reply. 70.41. What is the difference between the highest and the lowest Gross enrolment ratio (%) in Tertiary schools?
Provide a succinct answer. 56.86. 